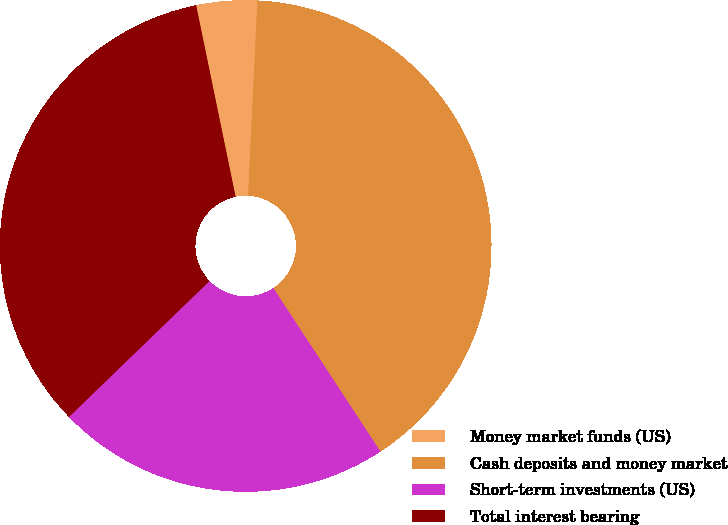Convert chart. <chart><loc_0><loc_0><loc_500><loc_500><pie_chart><fcel>Money market funds (US)<fcel>Cash deposits and money market<fcel>Short-term investments (US)<fcel>Total interest bearing<nl><fcel>4.0%<fcel>40.0%<fcel>22.0%<fcel>34.0%<nl></chart> 